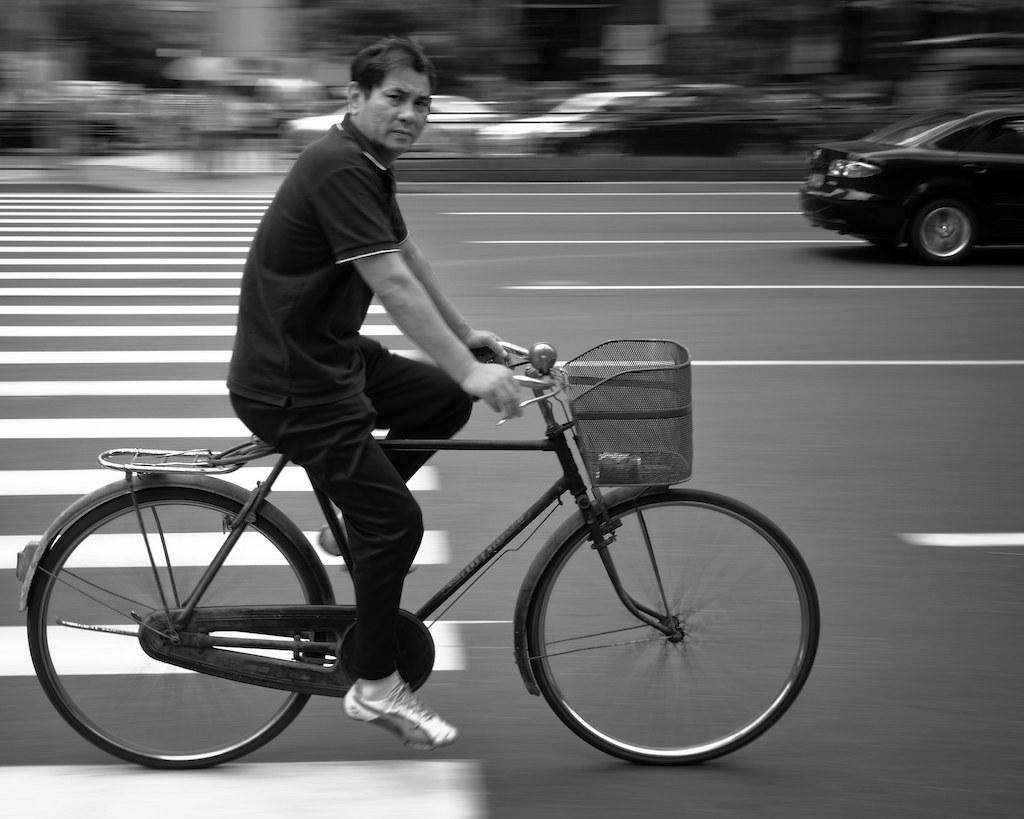Who is present in the image? There is a man in the image. What is the man doing in the image? The man is sitting on a bicycle. What is the color scheme of the image? The image is in black and white color. Where is the desk located in the image? There is no desk present in the image. What type of feast is being prepared in the image? There is no feast or any indication of food preparation in the image. 